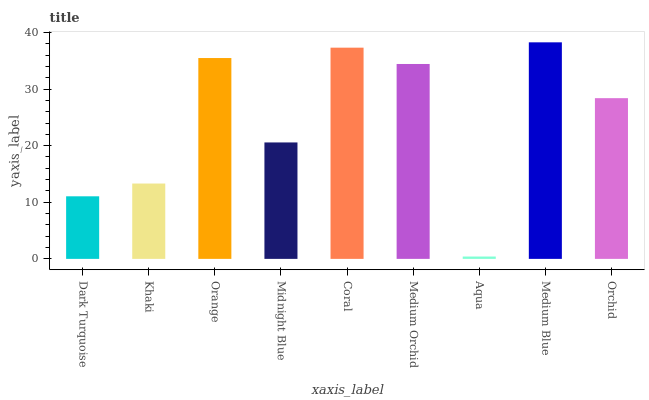Is Aqua the minimum?
Answer yes or no. Yes. Is Medium Blue the maximum?
Answer yes or no. Yes. Is Khaki the minimum?
Answer yes or no. No. Is Khaki the maximum?
Answer yes or no. No. Is Khaki greater than Dark Turquoise?
Answer yes or no. Yes. Is Dark Turquoise less than Khaki?
Answer yes or no. Yes. Is Dark Turquoise greater than Khaki?
Answer yes or no. No. Is Khaki less than Dark Turquoise?
Answer yes or no. No. Is Orchid the high median?
Answer yes or no. Yes. Is Orchid the low median?
Answer yes or no. Yes. Is Aqua the high median?
Answer yes or no. No. Is Medium Blue the low median?
Answer yes or no. No. 